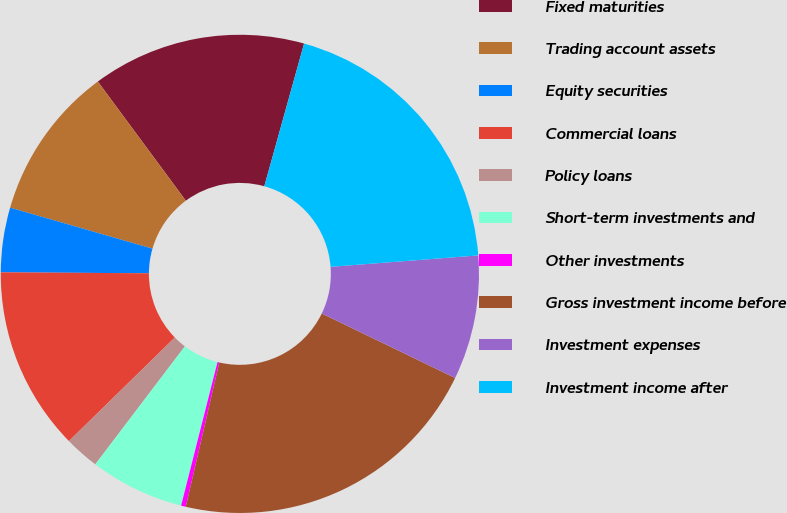Convert chart to OTSL. <chart><loc_0><loc_0><loc_500><loc_500><pie_chart><fcel>Fixed maturities<fcel>Trading account assets<fcel>Equity securities<fcel>Commercial loans<fcel>Policy loans<fcel>Short-term investments and<fcel>Other investments<fcel>Gross investment income before<fcel>Investment expenses<fcel>Investment income after<nl><fcel>14.45%<fcel>10.41%<fcel>4.36%<fcel>12.43%<fcel>2.34%<fcel>6.38%<fcel>0.32%<fcel>21.46%<fcel>8.4%<fcel>19.44%<nl></chart> 